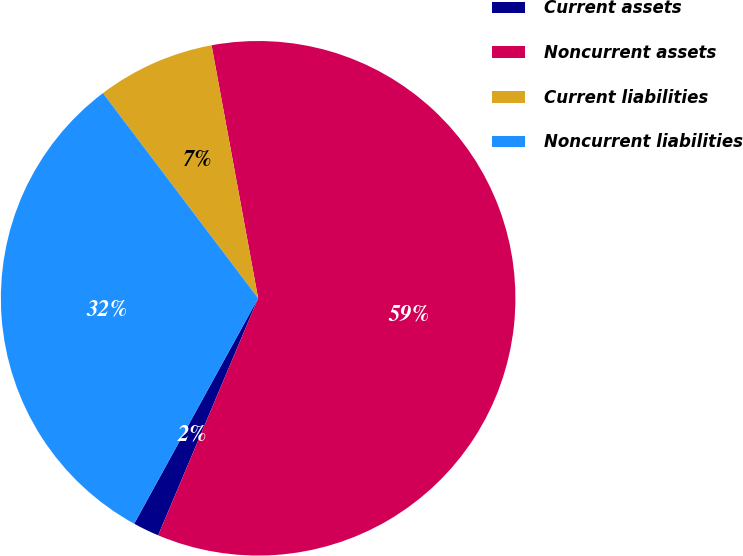Convert chart to OTSL. <chart><loc_0><loc_0><loc_500><loc_500><pie_chart><fcel>Current assets<fcel>Noncurrent assets<fcel>Current liabilities<fcel>Noncurrent liabilities<nl><fcel>1.65%<fcel>59.25%<fcel>7.41%<fcel>31.69%<nl></chart> 